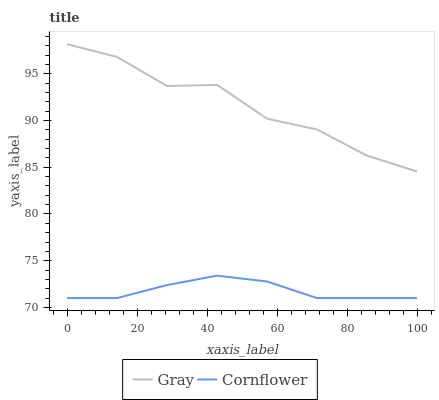Does Cornflower have the minimum area under the curve?
Answer yes or no. Yes. Does Gray have the maximum area under the curve?
Answer yes or no. Yes. Does Cornflower have the maximum area under the curve?
Answer yes or no. No. Is Cornflower the smoothest?
Answer yes or no. Yes. Is Gray the roughest?
Answer yes or no. Yes. Is Cornflower the roughest?
Answer yes or no. No. Does Cornflower have the lowest value?
Answer yes or no. Yes. Does Gray have the highest value?
Answer yes or no. Yes. Does Cornflower have the highest value?
Answer yes or no. No. Is Cornflower less than Gray?
Answer yes or no. Yes. Is Gray greater than Cornflower?
Answer yes or no. Yes. Does Cornflower intersect Gray?
Answer yes or no. No. 